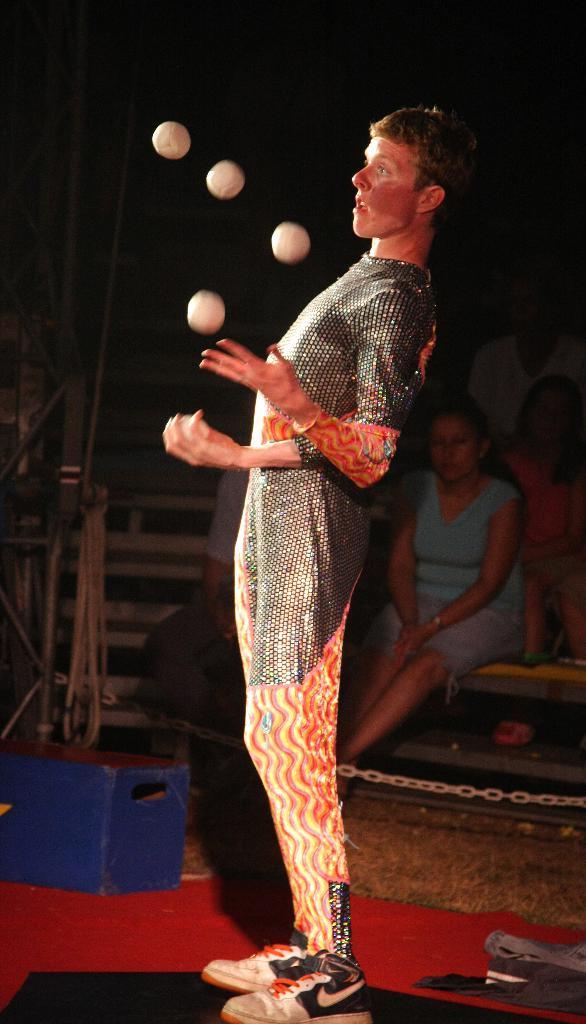How would you summarize this image in a sentence or two? In the picture I can see a man in the middle of the image. I can see a red carpet on the floor. I can see four balls in the air. I can see three persons on the right side. There is a man on the left side, though his face is not visible. I can see a blue color stock box on the carpet on the bottom left side. I can see a metal chain on the bottom right side. 